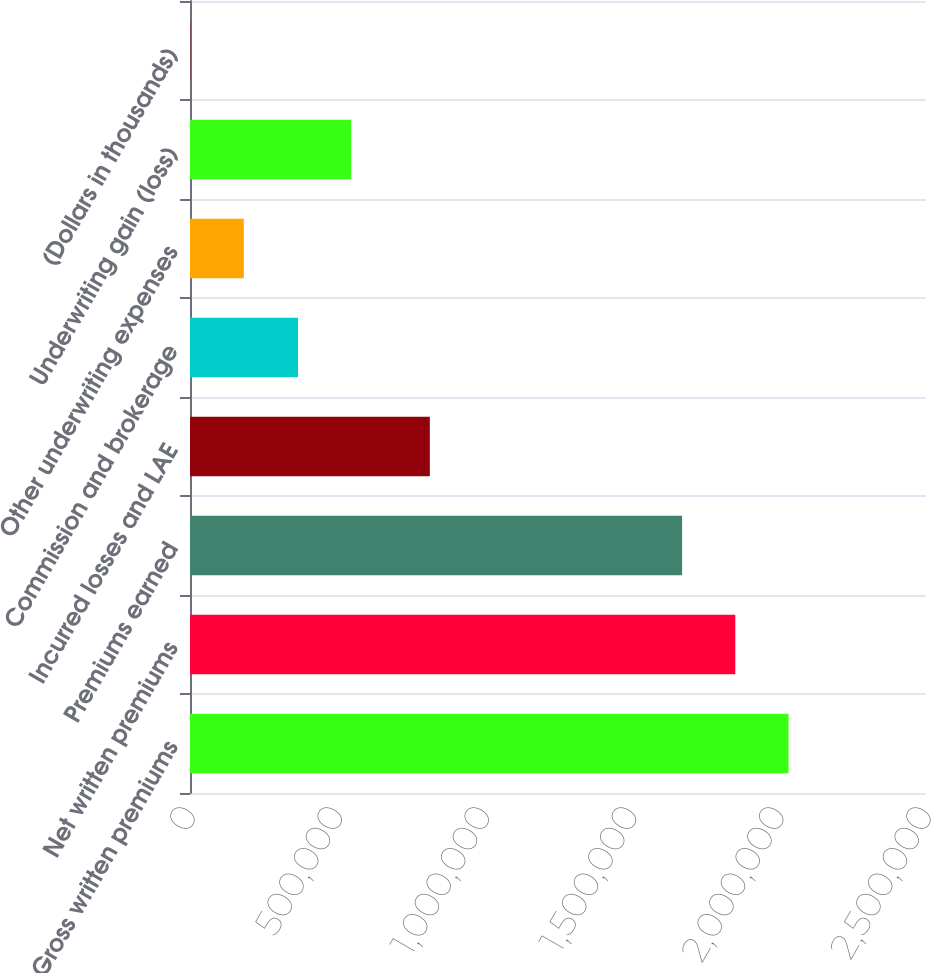<chart> <loc_0><loc_0><loc_500><loc_500><bar_chart><fcel>Gross written premiums<fcel>Net written premiums<fcel>Premiums earned<fcel>Incurred losses and LAE<fcel>Commission and brokerage<fcel>Other underwriting expenses<fcel>Underwriting gain (loss)<fcel>(Dollars in thousands)<nl><fcel>2.03304e+06<fcel>1.85228e+06<fcel>1.67151e+06<fcel>814668<fcel>366890<fcel>182779<fcel>547656<fcel>2013<nl></chart> 